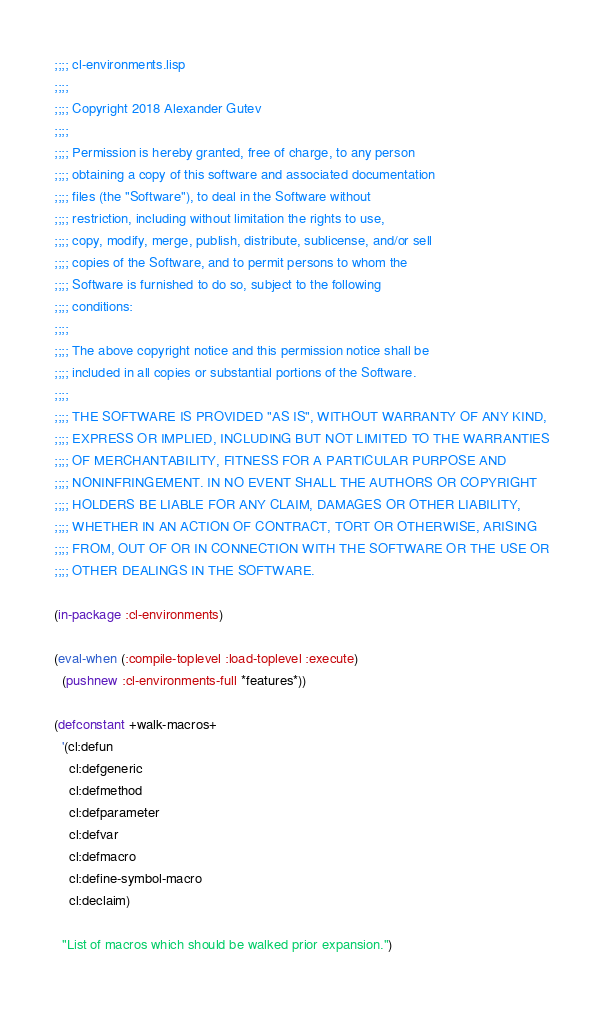Convert code to text. <code><loc_0><loc_0><loc_500><loc_500><_Lisp_>;;;; cl-environments.lisp
;;;;
;;;; Copyright 2018 Alexander Gutev
;;;;
;;;; Permission is hereby granted, free of charge, to any person
;;;; obtaining a copy of this software and associated documentation
;;;; files (the "Software"), to deal in the Software without
;;;; restriction, including without limitation the rights to use,
;;;; copy, modify, merge, publish, distribute, sublicense, and/or sell
;;;; copies of the Software, and to permit persons to whom the
;;;; Software is furnished to do so, subject to the following
;;;; conditions:
;;;;
;;;; The above copyright notice and this permission notice shall be
;;;; included in all copies or substantial portions of the Software.
;;;;
;;;; THE SOFTWARE IS PROVIDED "AS IS", WITHOUT WARRANTY OF ANY KIND,
;;;; EXPRESS OR IMPLIED, INCLUDING BUT NOT LIMITED TO THE WARRANTIES
;;;; OF MERCHANTABILITY, FITNESS FOR A PARTICULAR PURPOSE AND
;;;; NONINFRINGEMENT. IN NO EVENT SHALL THE AUTHORS OR COPYRIGHT
;;;; HOLDERS BE LIABLE FOR ANY CLAIM, DAMAGES OR OTHER LIABILITY,
;;;; WHETHER IN AN ACTION OF CONTRACT, TORT OR OTHERWISE, ARISING
;;;; FROM, OUT OF OR IN CONNECTION WITH THE SOFTWARE OR THE USE OR
;;;; OTHER DEALINGS IN THE SOFTWARE.

(in-package :cl-environments)

(eval-when (:compile-toplevel :load-toplevel :execute)
  (pushnew :cl-environments-full *features*))

(defconstant +walk-macros+
  '(cl:defun
    cl:defgeneric
    cl:defmethod
    cl:defparameter
    cl:defvar
    cl:defmacro
    cl:define-symbol-macro
    cl:declaim)

  "List of macros which should be walked prior expansion.")
</code> 